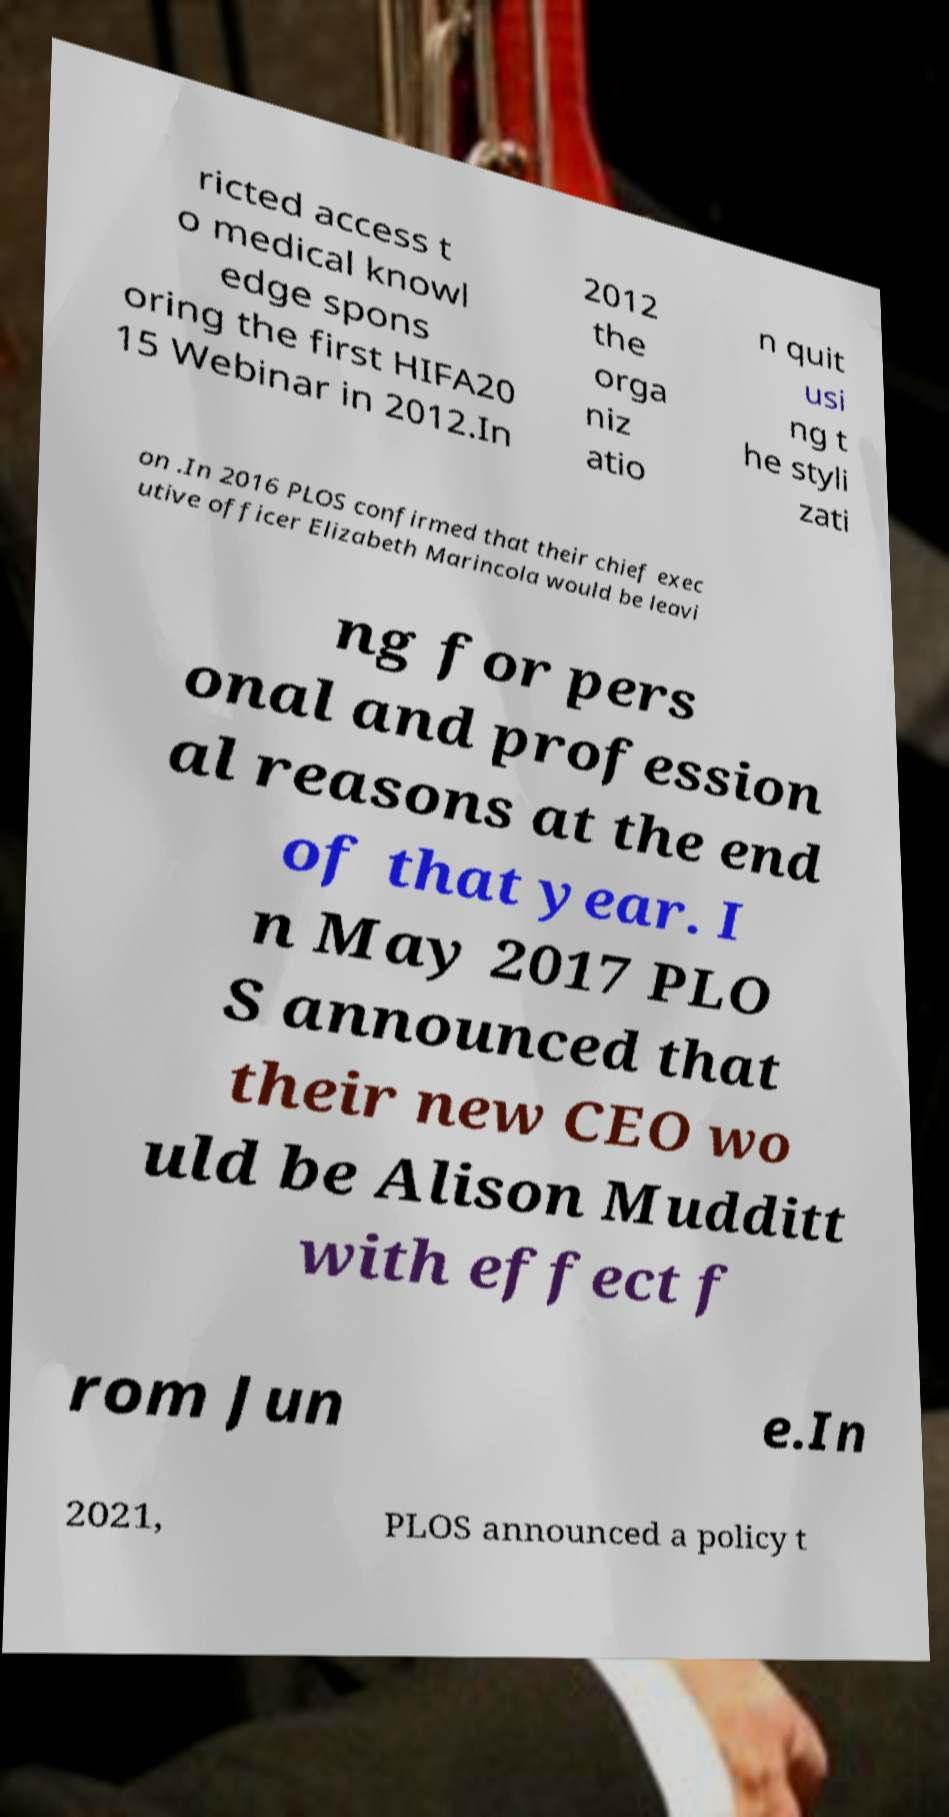Please identify and transcribe the text found in this image. ricted access t o medical knowl edge spons oring the first HIFA20 15 Webinar in 2012.In 2012 the orga niz atio n quit usi ng t he styli zati on .In 2016 PLOS confirmed that their chief exec utive officer Elizabeth Marincola would be leavi ng for pers onal and profession al reasons at the end of that year. I n May 2017 PLO S announced that their new CEO wo uld be Alison Mudditt with effect f rom Jun e.In 2021, PLOS announced a policy t 